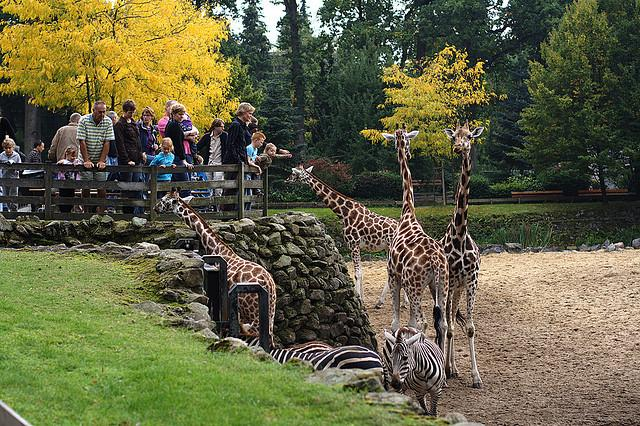What is closest to the giraffe? Please explain your reasoning. zebra. The zebra is close. 